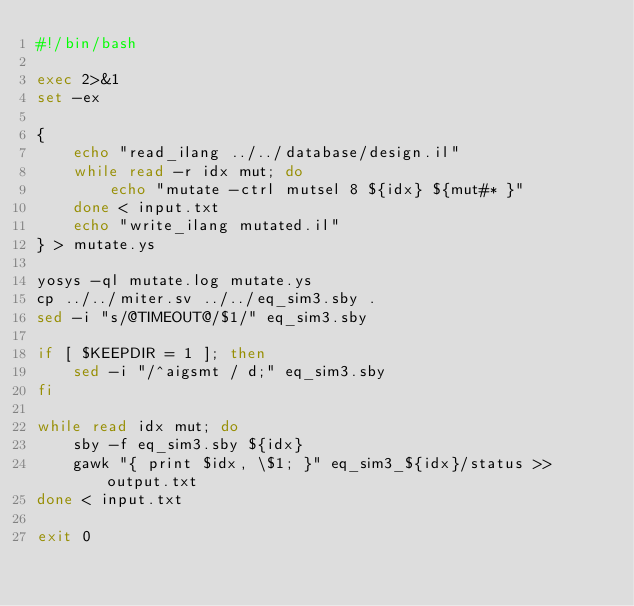Convert code to text. <code><loc_0><loc_0><loc_500><loc_500><_Bash_>#!/bin/bash

exec 2>&1
set -ex

{
	echo "read_ilang ../../database/design.il"
	while read -r idx mut; do
		echo "mutate -ctrl mutsel 8 ${idx} ${mut#* }"
	done < input.txt
	echo "write_ilang mutated.il"
} > mutate.ys

yosys -ql mutate.log mutate.ys
cp ../../miter.sv ../../eq_sim3.sby .
sed -i "s/@TIMEOUT@/$1/" eq_sim3.sby

if [ $KEEPDIR = 1 ]; then
	sed -i "/^aigsmt / d;" eq_sim3.sby
fi

while read idx mut; do
	sby -f eq_sim3.sby ${idx}
	gawk "{ print $idx, \$1; }" eq_sim3_${idx}/status >> output.txt
done < input.txt

exit 0
</code> 